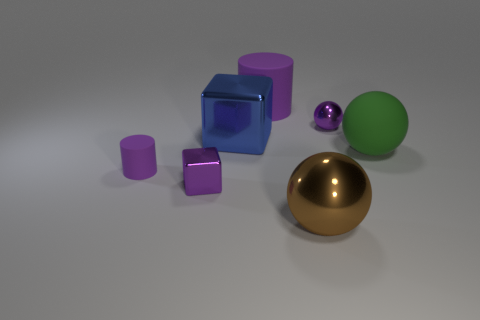What number of spheres are behind the big rubber ball?
Your answer should be very brief. 1. Are there more small gray matte cylinders than large things?
Offer a terse response. No. There is a purple metallic thing that is right of the large metallic thing behind the brown thing; what is its shape?
Offer a terse response. Sphere. Do the large metal block and the large cylinder have the same color?
Ensure brevity in your answer.  No. Are there more matte spheres that are behind the large rubber sphere than blue metal cubes?
Your response must be concise. No. There is a purple matte cylinder behind the green thing; what number of matte cylinders are in front of it?
Provide a short and direct response. 1. Does the purple cylinder that is on the left side of the small purple metal cube have the same material as the tiny purple object that is on the right side of the big brown ball?
Provide a short and direct response. No. There is a tiny cube that is the same color as the tiny shiny sphere; what is it made of?
Offer a terse response. Metal. What number of other purple things are the same shape as the big purple thing?
Offer a terse response. 1. Do the purple block and the purple cylinder in front of the large purple cylinder have the same material?
Your response must be concise. No. 